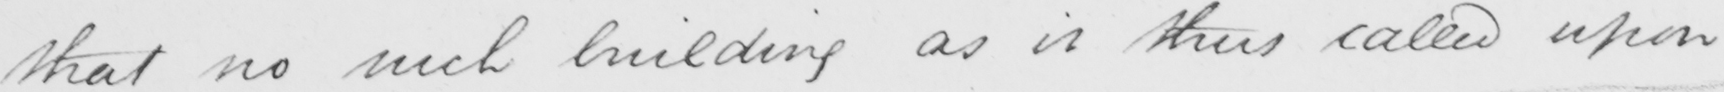Please provide the text content of this handwritten line. that no such building as it thus called upon 